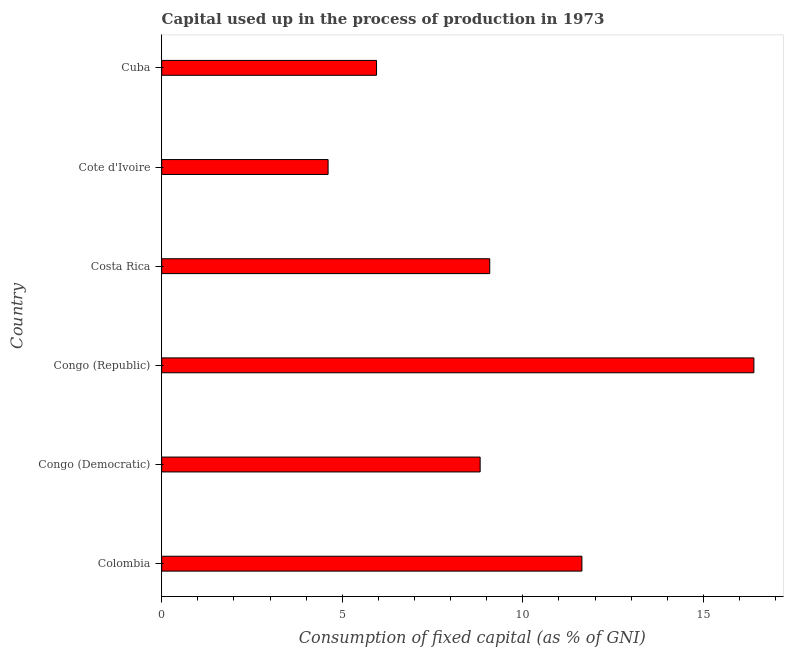Does the graph contain grids?
Your answer should be compact. No. What is the title of the graph?
Keep it short and to the point. Capital used up in the process of production in 1973. What is the label or title of the X-axis?
Keep it short and to the point. Consumption of fixed capital (as % of GNI). What is the consumption of fixed capital in Colombia?
Make the answer very short. 11.63. Across all countries, what is the maximum consumption of fixed capital?
Give a very brief answer. 16.4. Across all countries, what is the minimum consumption of fixed capital?
Make the answer very short. 4.61. In which country was the consumption of fixed capital maximum?
Your answer should be very brief. Congo (Republic). In which country was the consumption of fixed capital minimum?
Your response must be concise. Cote d'Ivoire. What is the sum of the consumption of fixed capital?
Provide a short and direct response. 56.48. What is the difference between the consumption of fixed capital in Congo (Republic) and Cote d'Ivoire?
Offer a very short reply. 11.79. What is the average consumption of fixed capital per country?
Your answer should be compact. 9.41. What is the median consumption of fixed capital?
Offer a very short reply. 8.95. What is the ratio of the consumption of fixed capital in Congo (Democratic) to that in Cuba?
Offer a very short reply. 1.48. Is the difference between the consumption of fixed capital in Congo (Republic) and Cuba greater than the difference between any two countries?
Your response must be concise. No. What is the difference between the highest and the second highest consumption of fixed capital?
Your answer should be compact. 4.76. Is the sum of the consumption of fixed capital in Colombia and Congo (Democratic) greater than the maximum consumption of fixed capital across all countries?
Provide a succinct answer. Yes. What is the difference between the highest and the lowest consumption of fixed capital?
Make the answer very short. 11.79. In how many countries, is the consumption of fixed capital greater than the average consumption of fixed capital taken over all countries?
Offer a very short reply. 2. What is the Consumption of fixed capital (as % of GNI) in Colombia?
Ensure brevity in your answer.  11.63. What is the Consumption of fixed capital (as % of GNI) of Congo (Democratic)?
Provide a succinct answer. 8.82. What is the Consumption of fixed capital (as % of GNI) in Congo (Republic)?
Provide a short and direct response. 16.4. What is the Consumption of fixed capital (as % of GNI) of Costa Rica?
Offer a terse response. 9.08. What is the Consumption of fixed capital (as % of GNI) of Cote d'Ivoire?
Make the answer very short. 4.61. What is the Consumption of fixed capital (as % of GNI) in Cuba?
Keep it short and to the point. 5.95. What is the difference between the Consumption of fixed capital (as % of GNI) in Colombia and Congo (Democratic)?
Provide a short and direct response. 2.82. What is the difference between the Consumption of fixed capital (as % of GNI) in Colombia and Congo (Republic)?
Provide a succinct answer. -4.76. What is the difference between the Consumption of fixed capital (as % of GNI) in Colombia and Costa Rica?
Ensure brevity in your answer.  2.55. What is the difference between the Consumption of fixed capital (as % of GNI) in Colombia and Cote d'Ivoire?
Give a very brief answer. 7.03. What is the difference between the Consumption of fixed capital (as % of GNI) in Colombia and Cuba?
Your answer should be compact. 5.69. What is the difference between the Consumption of fixed capital (as % of GNI) in Congo (Democratic) and Congo (Republic)?
Offer a terse response. -7.58. What is the difference between the Consumption of fixed capital (as % of GNI) in Congo (Democratic) and Costa Rica?
Give a very brief answer. -0.27. What is the difference between the Consumption of fixed capital (as % of GNI) in Congo (Democratic) and Cote d'Ivoire?
Your response must be concise. 4.21. What is the difference between the Consumption of fixed capital (as % of GNI) in Congo (Democratic) and Cuba?
Offer a terse response. 2.87. What is the difference between the Consumption of fixed capital (as % of GNI) in Congo (Republic) and Costa Rica?
Offer a terse response. 7.31. What is the difference between the Consumption of fixed capital (as % of GNI) in Congo (Republic) and Cote d'Ivoire?
Make the answer very short. 11.79. What is the difference between the Consumption of fixed capital (as % of GNI) in Congo (Republic) and Cuba?
Offer a very short reply. 10.45. What is the difference between the Consumption of fixed capital (as % of GNI) in Costa Rica and Cote d'Ivoire?
Make the answer very short. 4.48. What is the difference between the Consumption of fixed capital (as % of GNI) in Costa Rica and Cuba?
Give a very brief answer. 3.13. What is the difference between the Consumption of fixed capital (as % of GNI) in Cote d'Ivoire and Cuba?
Provide a succinct answer. -1.34. What is the ratio of the Consumption of fixed capital (as % of GNI) in Colombia to that in Congo (Democratic)?
Your response must be concise. 1.32. What is the ratio of the Consumption of fixed capital (as % of GNI) in Colombia to that in Congo (Republic)?
Keep it short and to the point. 0.71. What is the ratio of the Consumption of fixed capital (as % of GNI) in Colombia to that in Costa Rica?
Offer a very short reply. 1.28. What is the ratio of the Consumption of fixed capital (as % of GNI) in Colombia to that in Cote d'Ivoire?
Offer a terse response. 2.53. What is the ratio of the Consumption of fixed capital (as % of GNI) in Colombia to that in Cuba?
Your answer should be very brief. 1.96. What is the ratio of the Consumption of fixed capital (as % of GNI) in Congo (Democratic) to that in Congo (Republic)?
Keep it short and to the point. 0.54. What is the ratio of the Consumption of fixed capital (as % of GNI) in Congo (Democratic) to that in Costa Rica?
Make the answer very short. 0.97. What is the ratio of the Consumption of fixed capital (as % of GNI) in Congo (Democratic) to that in Cote d'Ivoire?
Keep it short and to the point. 1.91. What is the ratio of the Consumption of fixed capital (as % of GNI) in Congo (Democratic) to that in Cuba?
Your response must be concise. 1.48. What is the ratio of the Consumption of fixed capital (as % of GNI) in Congo (Republic) to that in Costa Rica?
Make the answer very short. 1.8. What is the ratio of the Consumption of fixed capital (as % of GNI) in Congo (Republic) to that in Cote d'Ivoire?
Provide a short and direct response. 3.56. What is the ratio of the Consumption of fixed capital (as % of GNI) in Congo (Republic) to that in Cuba?
Your response must be concise. 2.76. What is the ratio of the Consumption of fixed capital (as % of GNI) in Costa Rica to that in Cote d'Ivoire?
Offer a very short reply. 1.97. What is the ratio of the Consumption of fixed capital (as % of GNI) in Costa Rica to that in Cuba?
Your answer should be compact. 1.53. What is the ratio of the Consumption of fixed capital (as % of GNI) in Cote d'Ivoire to that in Cuba?
Offer a terse response. 0.78. 